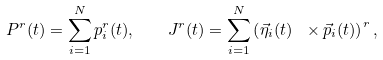<formula> <loc_0><loc_0><loc_500><loc_500>P ^ { r } ( t ) = \sum _ { i = 1 } ^ { N } p ^ { r } _ { i } ( t ) , \quad J ^ { r } ( t ) = \sum _ { i = 1 } ^ { N } \left ( { \vec { \eta } } _ { i } ( t ) \ \times { \vec { p } } _ { i } ( t ) \right ) ^ { r } ,</formula> 